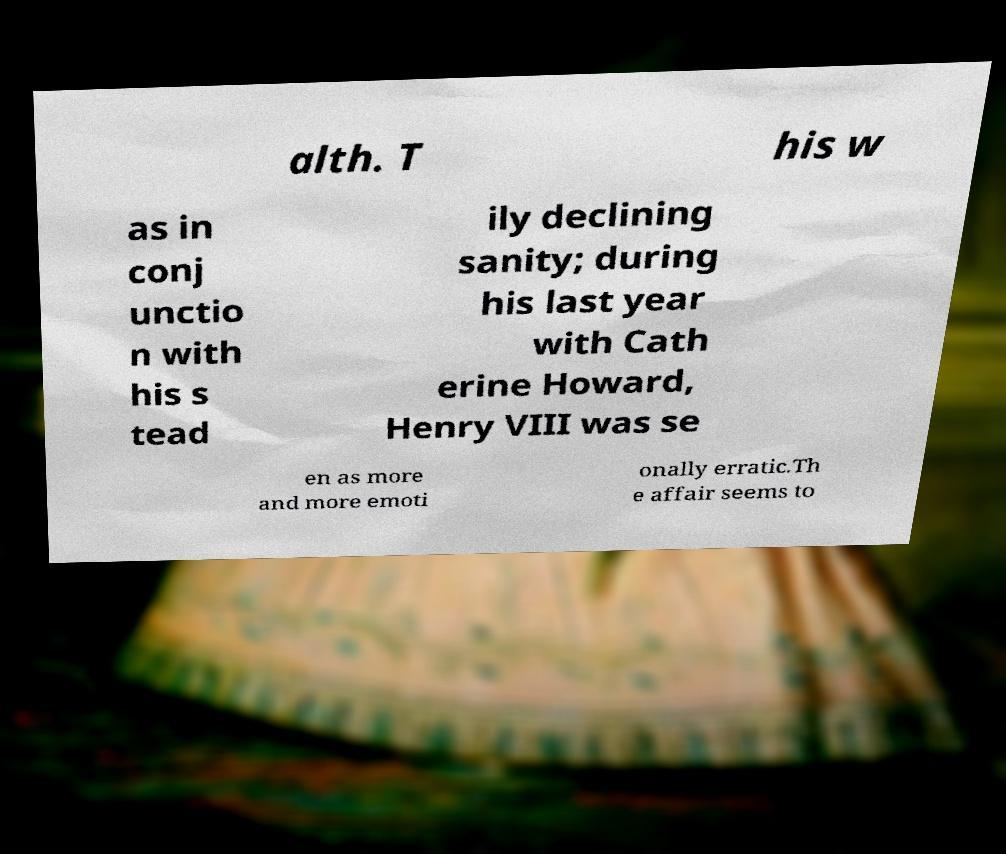I need the written content from this picture converted into text. Can you do that? alth. T his w as in conj unctio n with his s tead ily declining sanity; during his last year with Cath erine Howard, Henry VIII was se en as more and more emoti onally erratic.Th e affair seems to 